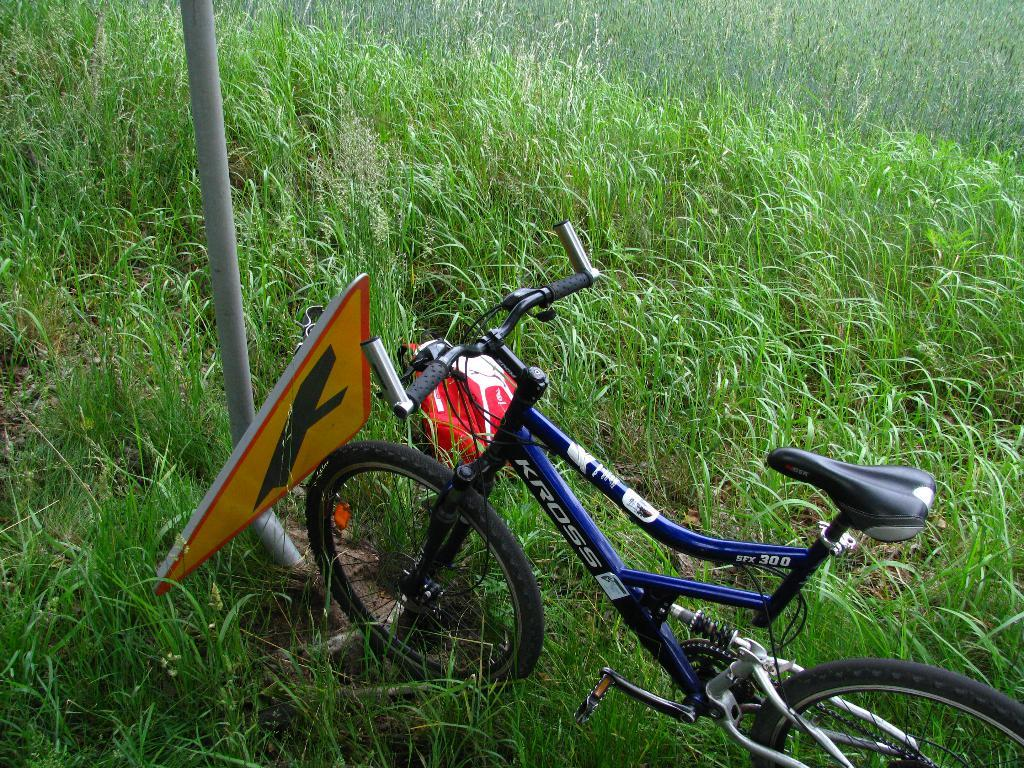What is the main object in the image? There is a bicycle in the image. What else can be seen in the image besides the bicycle? There is a bag, a board, a pole, and grass visible in the image. Can you describe the surface on which the bicycle is placed? The grass in the image suggests that the bicycle is on a grassy surface. What might the bag be used for in the image? The bag could be used for carrying items or belongings. How does the bicycle hate the island in the image? There is no island present in the image, and bicycles do not have the ability to hate. 